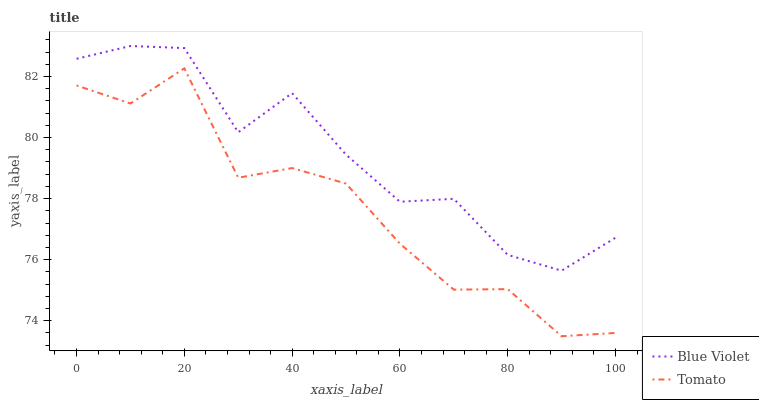Does Tomato have the minimum area under the curve?
Answer yes or no. Yes. Does Blue Violet have the maximum area under the curve?
Answer yes or no. Yes. Does Blue Violet have the minimum area under the curve?
Answer yes or no. No. Is Blue Violet the smoothest?
Answer yes or no. Yes. Is Tomato the roughest?
Answer yes or no. Yes. Is Blue Violet the roughest?
Answer yes or no. No. Does Tomato have the lowest value?
Answer yes or no. Yes. Does Blue Violet have the lowest value?
Answer yes or no. No. Does Blue Violet have the highest value?
Answer yes or no. Yes. Is Tomato less than Blue Violet?
Answer yes or no. Yes. Is Blue Violet greater than Tomato?
Answer yes or no. Yes. Does Tomato intersect Blue Violet?
Answer yes or no. No. 